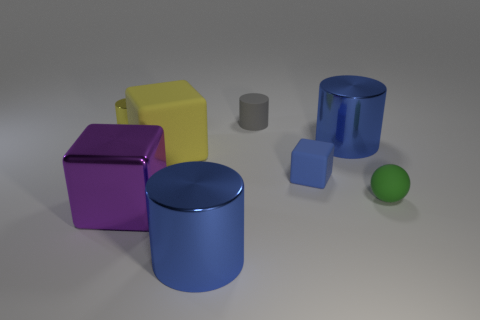The surfaces of these objects seem to have different finishes. Could you describe them? Certainly, the objects present a variety of finishes. The blue and purple objects have a high-gloss finish, indicated by strong specular highlights and clear reflections. The yellow cube has a less reflective, matte finish, while the green ball appears to have a slightly textured surface with diffuse reflections, which suggests it might be rubbery. 